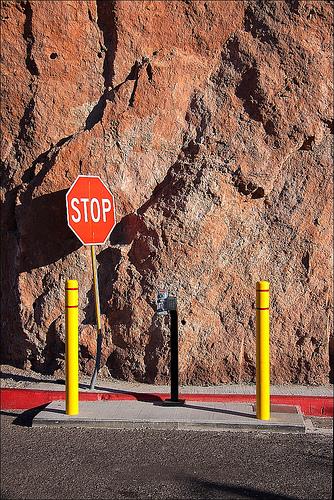What function do the yellow poles serve?
Answer briefly. For safety. What color is the rock in the background?
Keep it brief. Red. What is  on the black pole?
Quick response, please. Meter. 